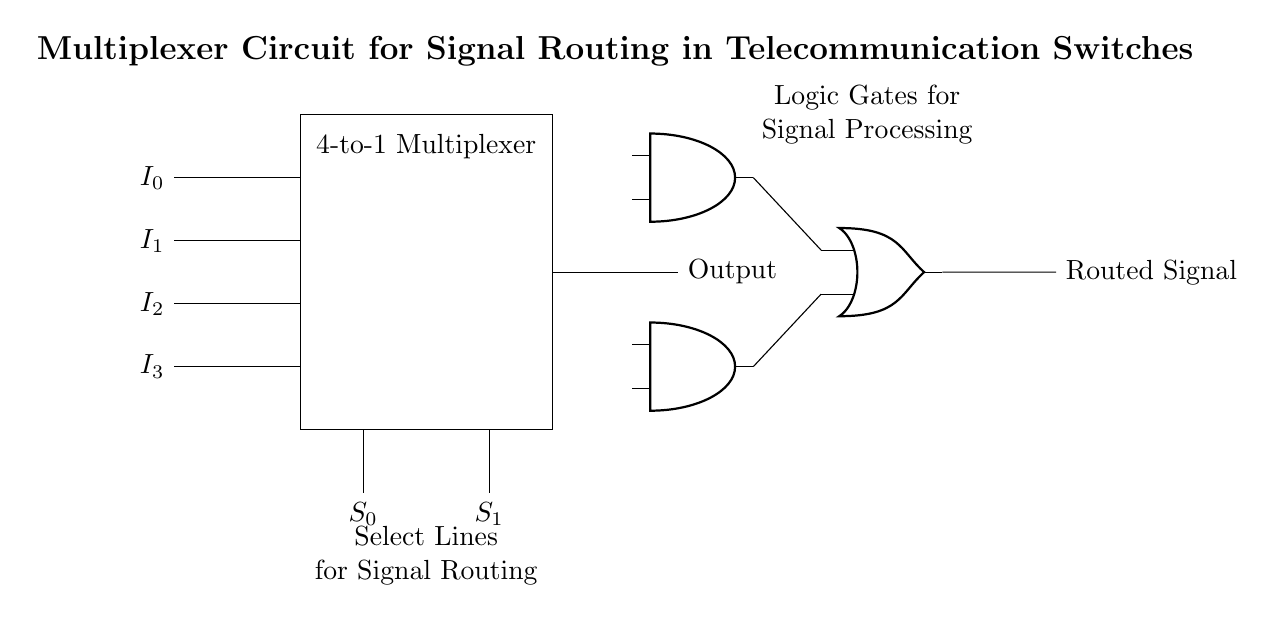What type of circuit is represented? This circuit is a 4-to-1 multiplexer. The diagram clearly labels the component at the center as a "4-to-1 Multiplexer" and shows input and select lines connected to it.
Answer: 4-to-1 multiplexer How many input lines does this multiplexer have? The diagram displays four input lines labeled I0, I1, I2, and I3. These are clearly shown on the left side of the multiplexer.
Answer: Four What are the select lines labeled? The select lines are labeled S0 and S1, as indicated in the diagram. They are positioned below the multiplexer symbol, connecting to it from the bottom.
Answer: S0 and S1 What is the output label of this circuit component? The output label next to the output line states "Output," which indicates the resulting signal from the multiplexer. This label is placed to the right of the multiplexer output connection.
Answer: Output Which logic gates are used in this circuit? The circuit includes two AND gates and one OR gate. The AND gates are labeled, and they connect to the OR gate, which processes their outputs.
Answer: AND and OR gates How does the multiplexer decide which input to route to the output? The selection is done by the select lines S0 and S1, which determine the active input based on their binary value. Each combination of S0 and S1 corresponds to one of the four inputs (I0 to I3) being routed to the output according to standard multiplexer operations.
Answer: By select lines S0 and S1 